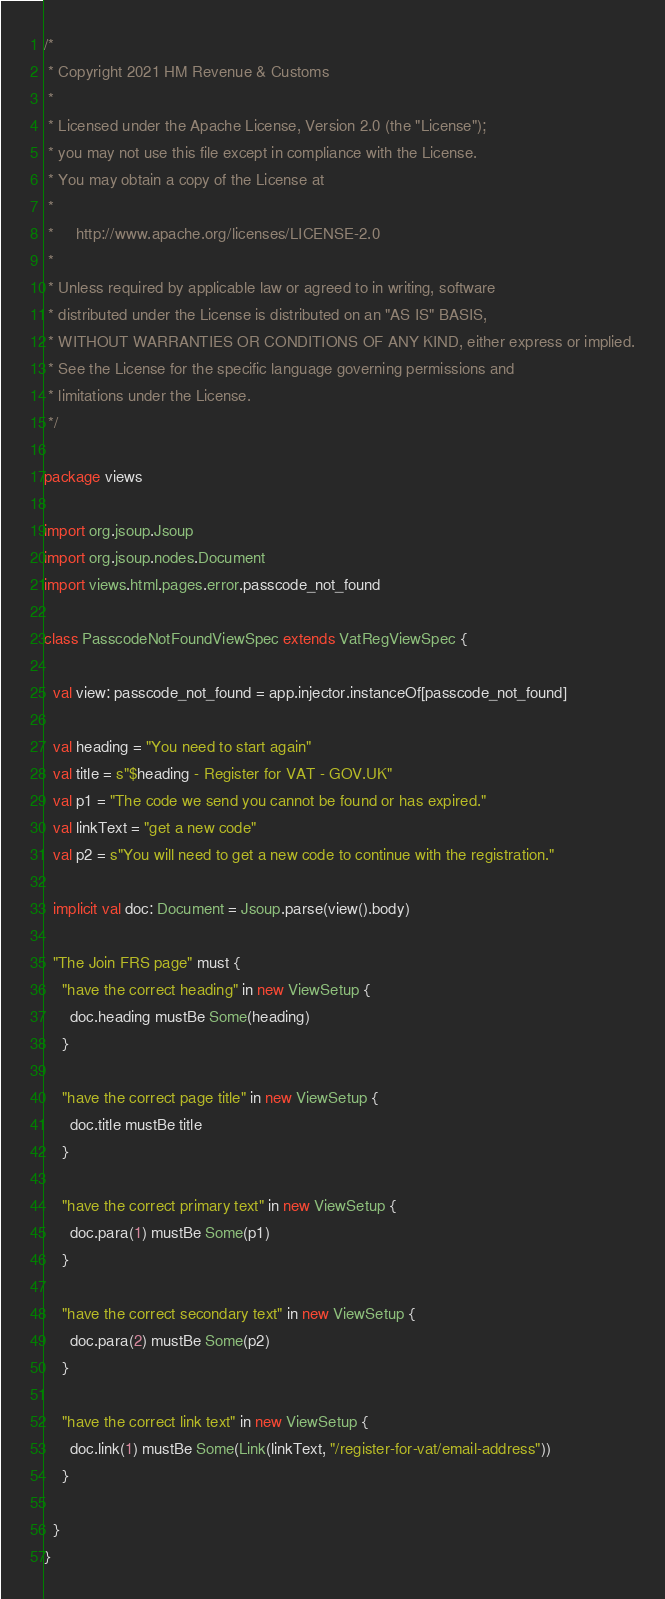<code> <loc_0><loc_0><loc_500><loc_500><_Scala_>/*
 * Copyright 2021 HM Revenue & Customs
 *
 * Licensed under the Apache License, Version 2.0 (the "License");
 * you may not use this file except in compliance with the License.
 * You may obtain a copy of the License at
 *
 *     http://www.apache.org/licenses/LICENSE-2.0
 *
 * Unless required by applicable law or agreed to in writing, software
 * distributed under the License is distributed on an "AS IS" BASIS,
 * WITHOUT WARRANTIES OR CONDITIONS OF ANY KIND, either express or implied.
 * See the License for the specific language governing permissions and
 * limitations under the License.
 */

package views

import org.jsoup.Jsoup
import org.jsoup.nodes.Document
import views.html.pages.error.passcode_not_found

class PasscodeNotFoundViewSpec extends VatRegViewSpec {

  val view: passcode_not_found = app.injector.instanceOf[passcode_not_found]

  val heading = "You need to start again"
  val title = s"$heading - Register for VAT - GOV.UK"
  val p1 = "The code we send you cannot be found or has expired."
  val linkText = "get a new code"
  val p2 = s"You will need to get a new code to continue with the registration."

  implicit val doc: Document = Jsoup.parse(view().body)

  "The Join FRS page" must {
    "have the correct heading" in new ViewSetup {
      doc.heading mustBe Some(heading)
    }

    "have the correct page title" in new ViewSetup {
      doc.title mustBe title
    }

    "have the correct primary text" in new ViewSetup {
      doc.para(1) mustBe Some(p1)
    }

    "have the correct secondary text" in new ViewSetup {
      doc.para(2) mustBe Some(p2)
    }

    "have the correct link text" in new ViewSetup {
      doc.link(1) mustBe Some(Link(linkText, "/register-for-vat/email-address"))
    }

  }
}
</code> 